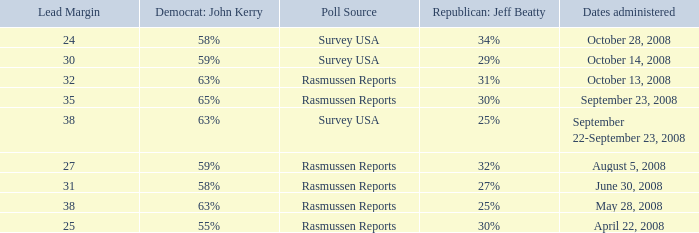What are the dates where democrat john kerry is 63% and poll source is rasmussen reports? October 13, 2008, May 28, 2008. 